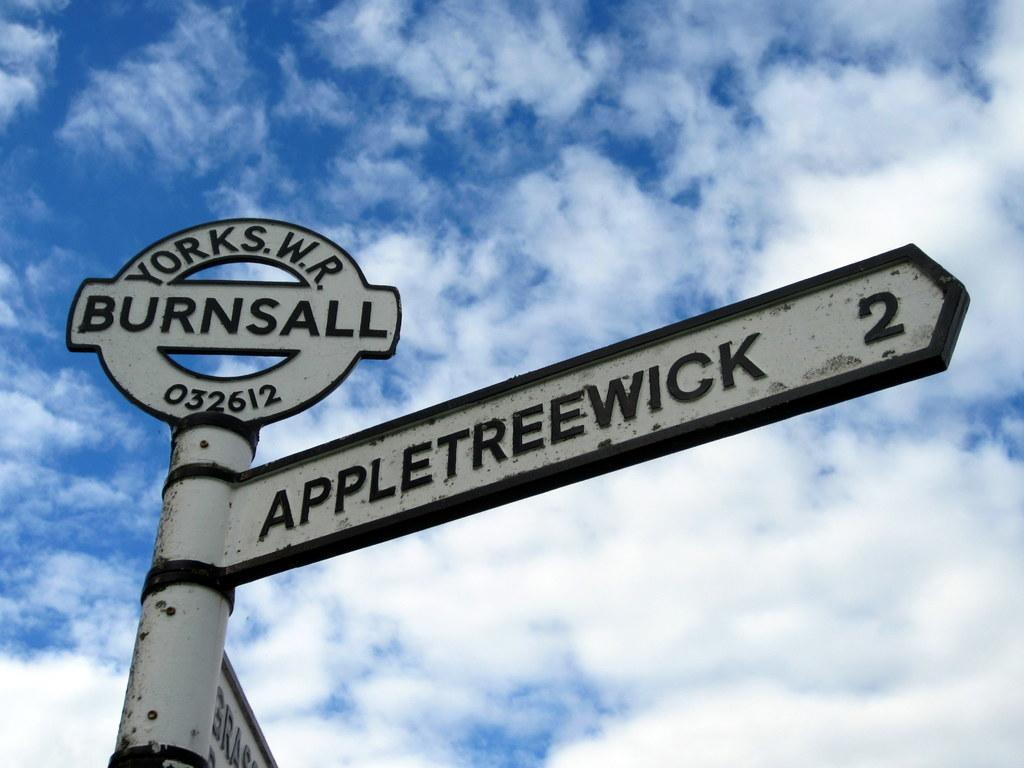<image>
Share a concise interpretation of the image provided. A street sign that says Appletreewick on a post. 